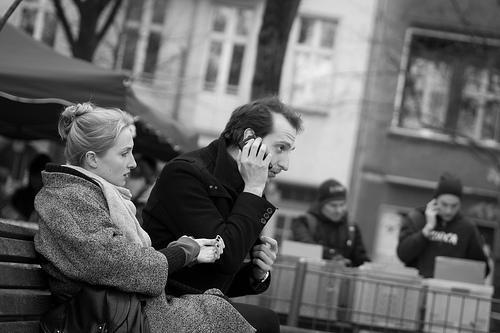How many people are in the photo?
Give a very brief answer. 4. 